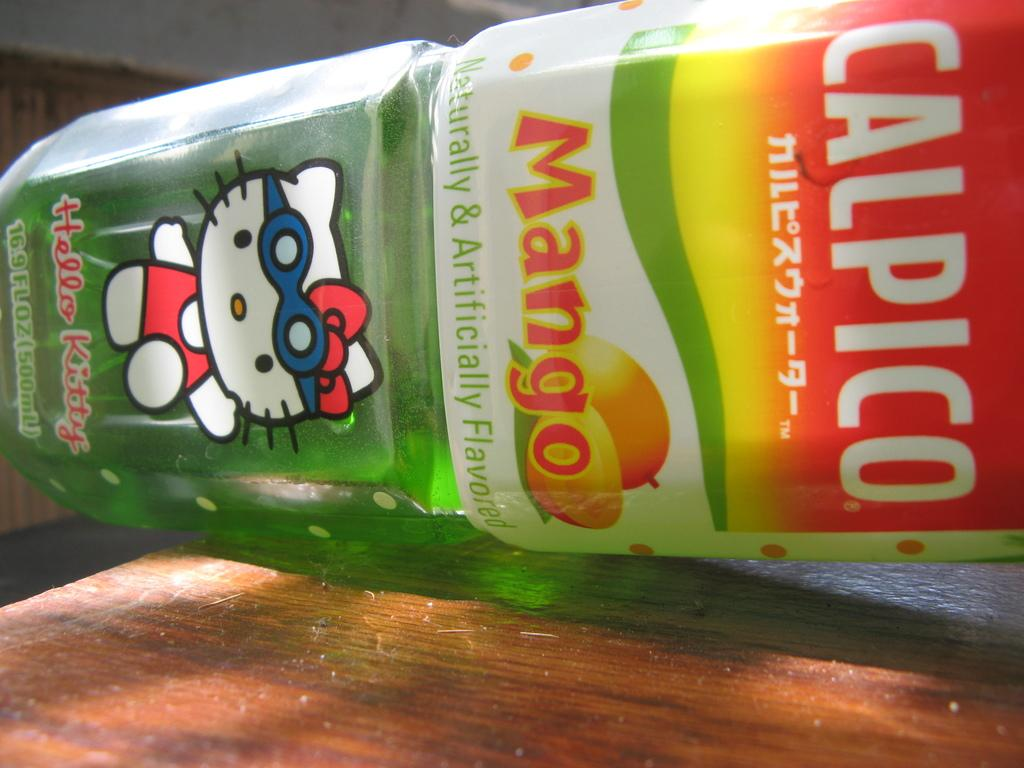<image>
Summarize the visual content of the image. A bottle of Calpico Mango Juice has a Hello Kitty on the front 